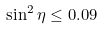Convert formula to latex. <formula><loc_0><loc_0><loc_500><loc_500>\sin ^ { 2 } \eta \leq 0 . 0 9</formula> 